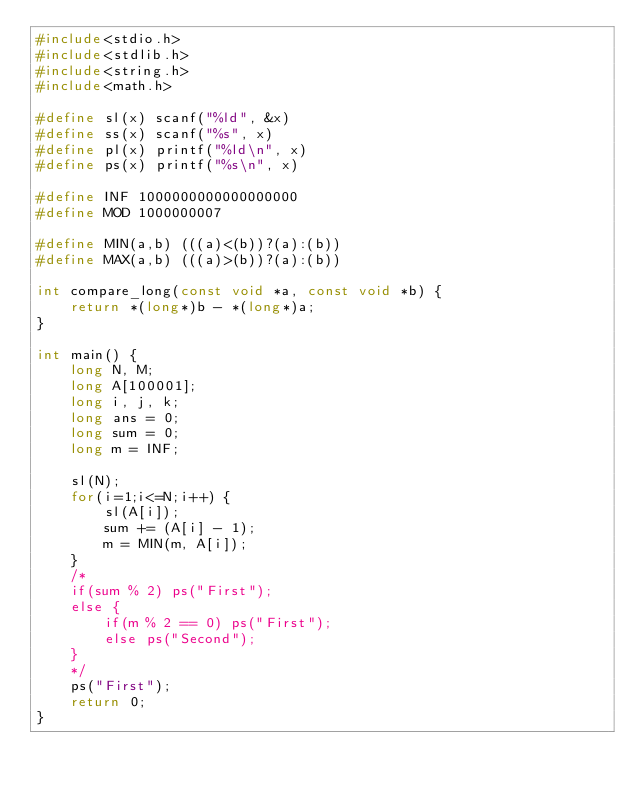<code> <loc_0><loc_0><loc_500><loc_500><_C_>#include<stdio.h>
#include<stdlib.h>
#include<string.h>
#include<math.h>
 
#define sl(x) scanf("%ld", &x)
#define ss(x) scanf("%s", x)
#define pl(x) printf("%ld\n", x)
#define ps(x) printf("%s\n", x)
 
#define INF 1000000000000000000
#define MOD 1000000007
 
#define MIN(a,b) (((a)<(b))?(a):(b))
#define MAX(a,b) (((a)>(b))?(a):(b))

int compare_long(const void *a, const void *b) {
	return *(long*)b - *(long*)a;
}

int main() {
	long N, M;
	long A[100001];
	long i, j, k;
	long ans = 0;
	long sum = 0;
	long m = INF;
	
	sl(N);
	for(i=1;i<=N;i++) {
		sl(A[i]);
		sum += (A[i] - 1);
		m = MIN(m, A[i]);
	}
	/*
	if(sum % 2) ps("First");
	else {
		if(m % 2 == 0) ps("First");
		else ps("Second");
	}
	*/
	ps("First");
	return 0;
}</code> 